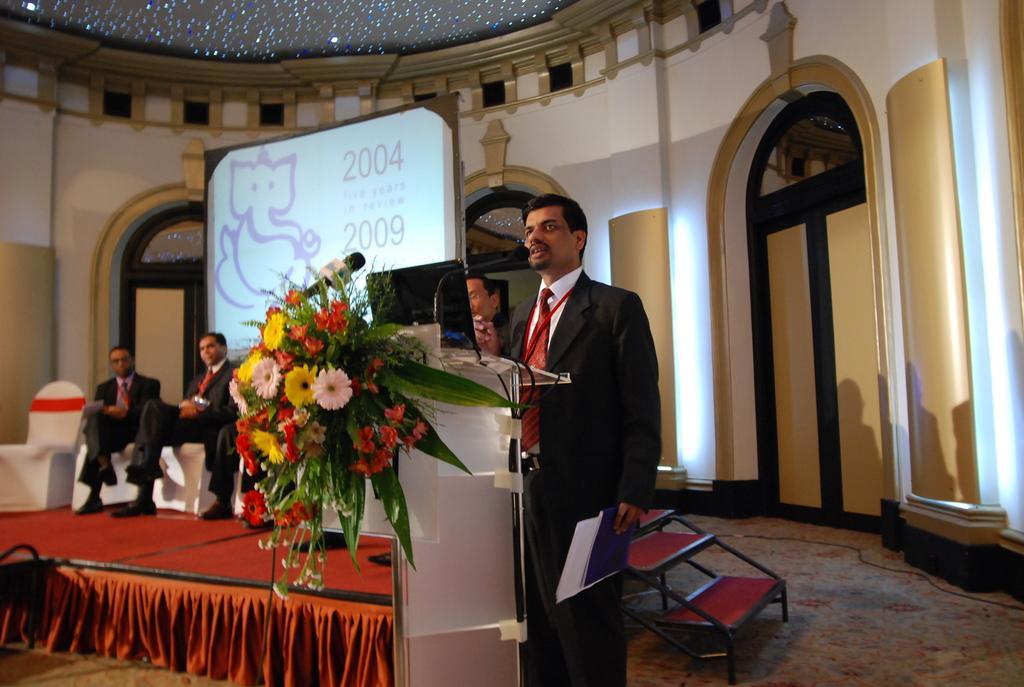Describe this image in one or two sentences. As we can see in the image there is a conference hall where a man is speaking on the mike, in front of him there is a podium and a beautiful bouquet of flowers is attached to the podium. Beside the man there is a stage and its of red carpet. The two men are sitting on the stage and behind them there is screen on which the idol of Lord Ganesha is seen. On the top of the conference hall there is a way of lights and it resembles like stars and the conference hall is very huge. 